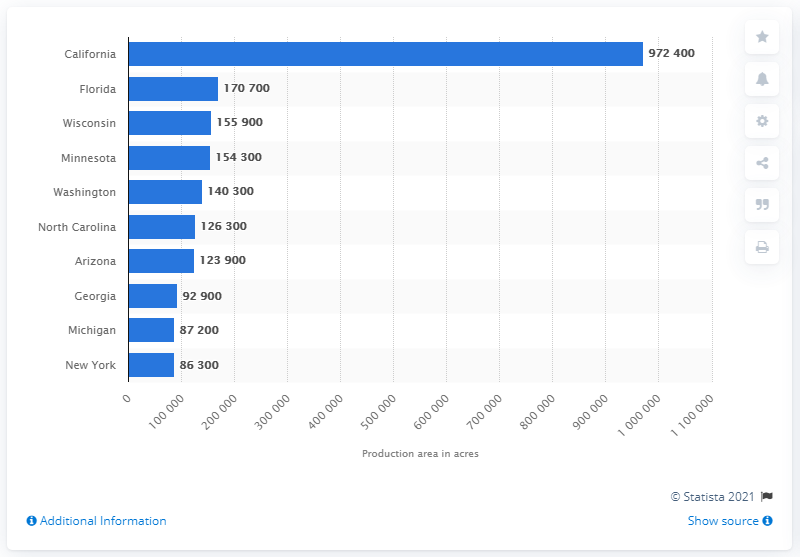Give some essential details in this illustration. In 2019, a total of 972,400 hectares of land was used as a production area for principal vegetables in California. 